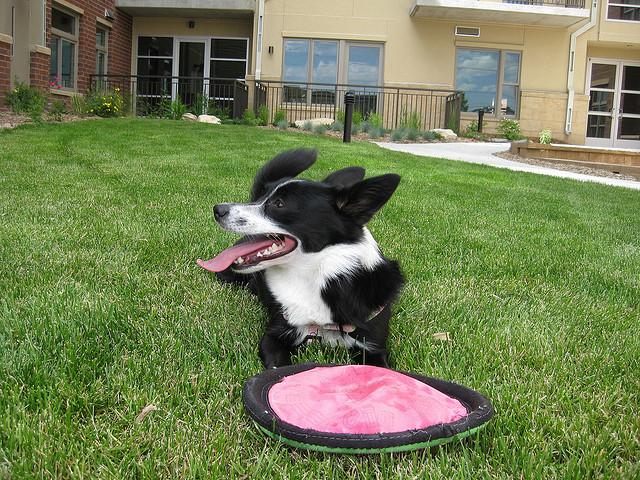Is the grass green?
Keep it brief. Yes. Is the dog playing with a ball?
Quick response, please. No. Can you see the sky?
Give a very brief answer. No. 